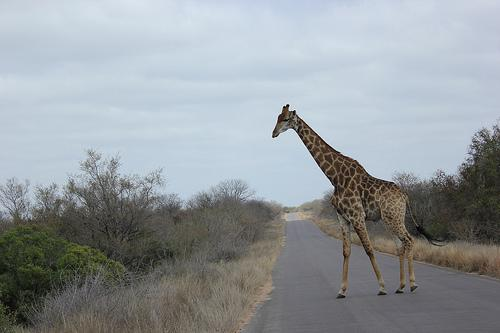Question: what color is the lower half of the giraffe's tail?
Choices:
A. Brown.
B. White.
C. Tan.
D. Black.
Answer with the letter. Answer: D Question: what direction is the giraffe facing?
Choices:
A. The right.
B. Forward.
C. The left.
D. Backwards.
Answer with the letter. Answer: C Question: what does the sky look like?
Choices:
A. Sunny.
B. Cloudy.
C. Overcast.
D. Hazy.
Answer with the letter. Answer: B Question: how many giraffes are shown?
Choices:
A. Two.
B. Three.
C. One.
D. Four.
Answer with the letter. Answer: C Question: what is next to the road on either side?
Choices:
A. Trees.
B. Grass.
C. Rocks.
D. Flowers.
Answer with the letter. Answer: B Question: how many hooves are flat against the road?
Choices:
A. Eight.
B. Six.
C. Two.
D. Three.
Answer with the letter. Answer: D 